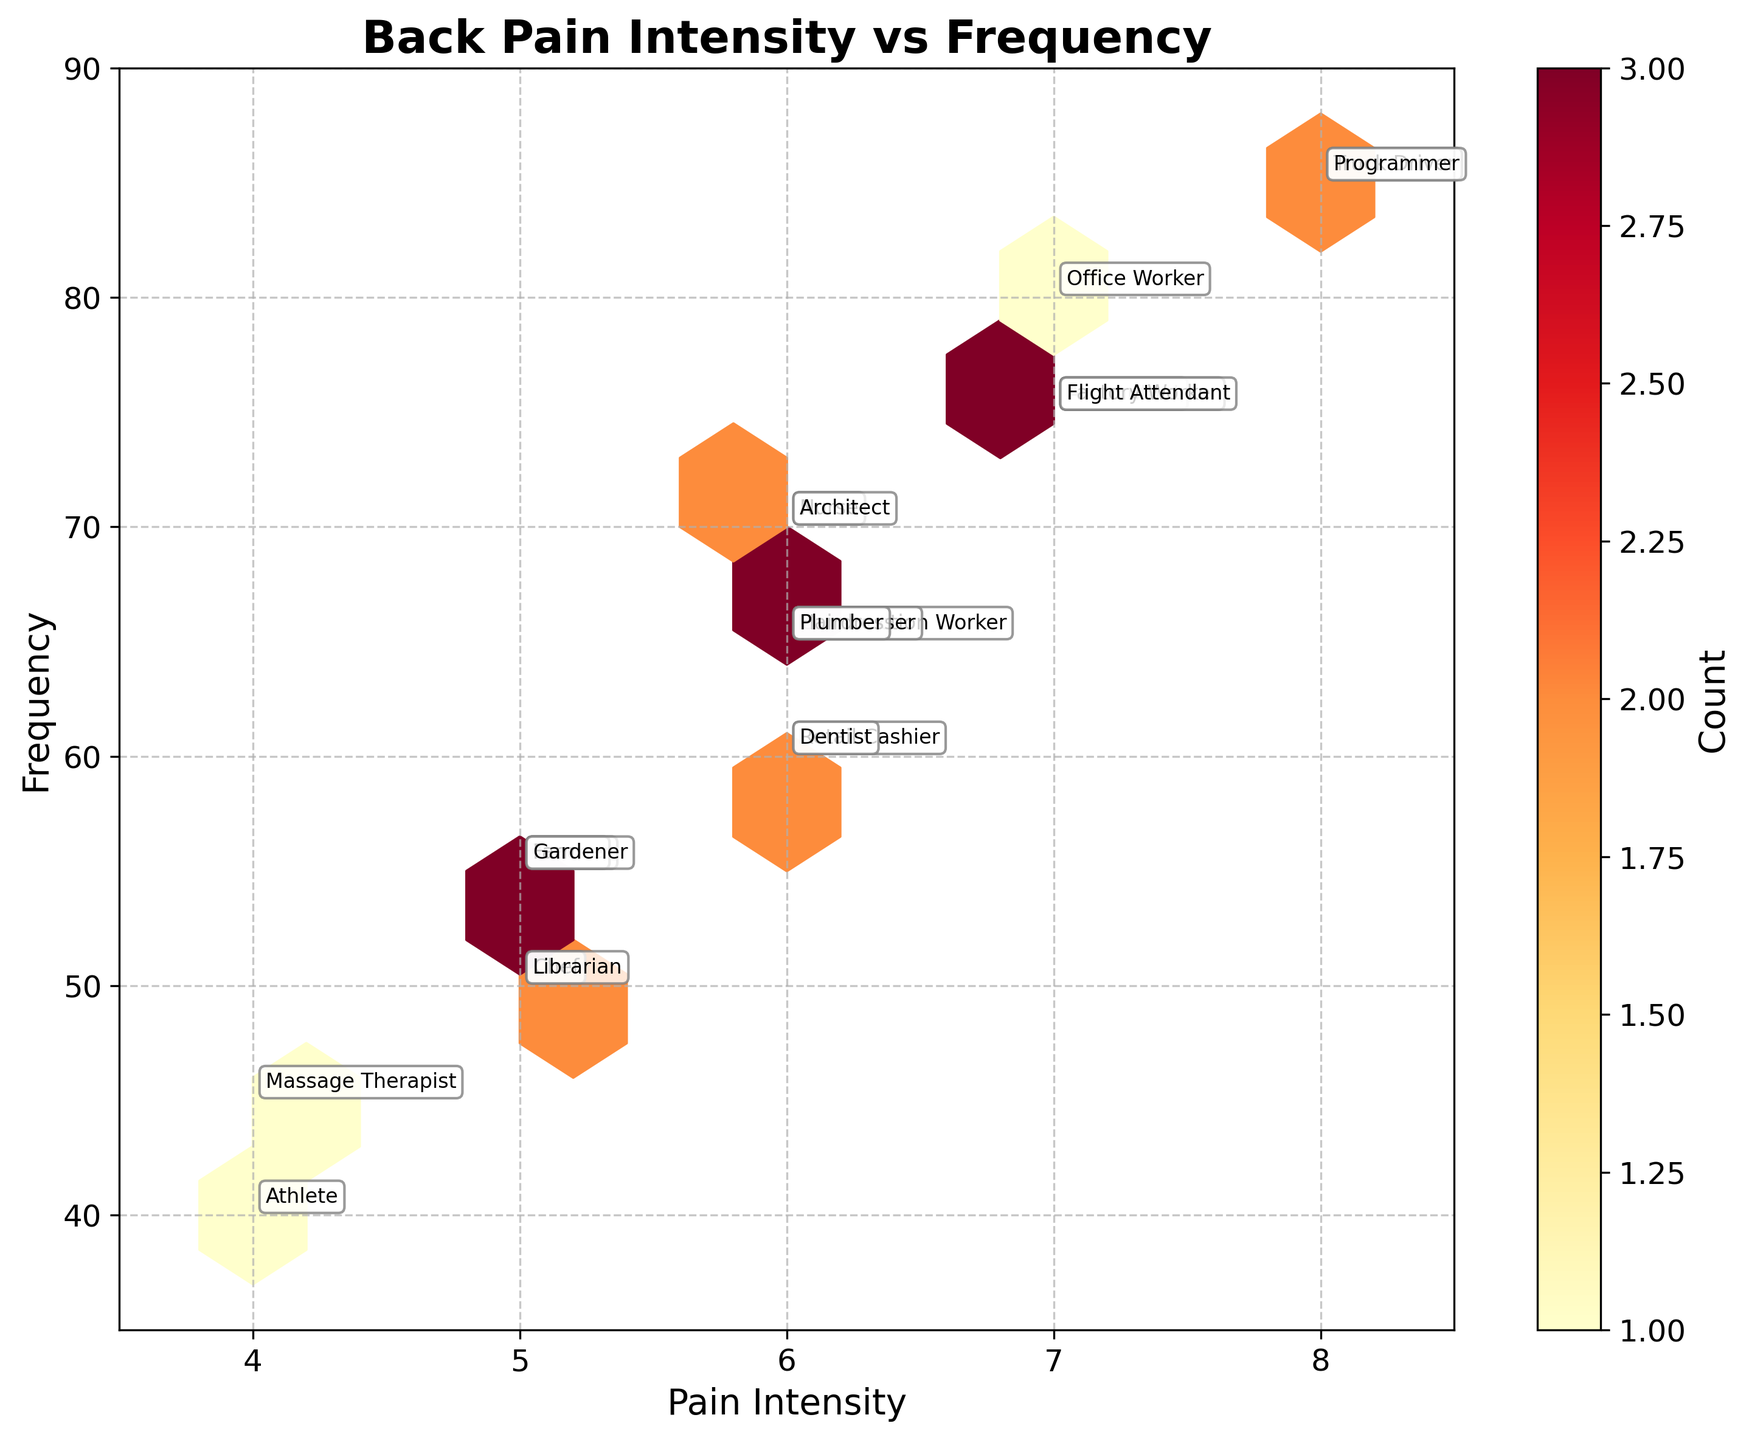what is the title of the plot? The title is displayed prominently at the top of the hexbin plot. It reads 'Back Pain Intensity vs Frequency'.
Answer: Back Pain Intensity vs Frequency how many data points have a pain intensity of 7? To determine the number of data points with a pain intensity of 7, look at the vertical position of hexagons aligned with 7 on the x-axis. Examine the color shades which indicate the count. There are multiple data points because the hexbin plot indicates overlaps by color density.
Answer: Multiple (shade shows overlaps) which profession has the highest reported pain frequency? Check the y-axis to find the highest value. Then trace horizontally to see which occupation is annotated at that point. 'Truck Driver' and 'Programmer' both report a frequency of 85, the highest on the chart.
Answer: Truck Driver, Programmer are there more data points with a pain intensity level of 5 or 8? Look at the distribution of hexagons and their color density on the x-axis at points 5 and 8. The color will indicate the relative number of data points. Pain intensity level 5 has more data points compared to 8.
Answer: Pain intensity level 5 is the frequency of pain higher in sedentary or active occupations? Examine the annotations to see which points correspond to sedentary and active occupations, then compare their y-axis (frequency) values. Sedentary occupations like 'Office Worker,' 'Truck Driver,' and 'Programmer' have higher frequency values compared to many active occupations.
Answer: Sedentary occupations what is the general trend between pain intensity and frequency? Observe the overall layout of hexagons. Higher frequencies cluster towards higher pain intensities, especially around 7 and 8, showing a positive correlation.
Answer: Positive correlation among the occupations with standing lifestyle, which has the lowest pain frequency? Identify the occupations marked with 'Standing' in the plot, then find the one with the lowest y-axis value. 'Retail Cashier' and 'Chef' show the lowest pain frequencies among standing occupations with values around 60 and 50.
Answer: Retail Cashier, Chef which occupation with moderate lifestyle reports the highest pain intensity? Identify and compare the positions of the occupations with a 'Moderate' lifestyle on the x-axis. 'Flight Attendant' shows the highest pain intensity value of 7.
Answer: Flight Attendant what is the average frequency of pain for active lifestyles? Locate the data points annotated with 'Active', then average their y-values (frequencies). Active occupations have frequencies like 65, 70, 55, etc., averaging around 61.
Answer: Approximately 61 